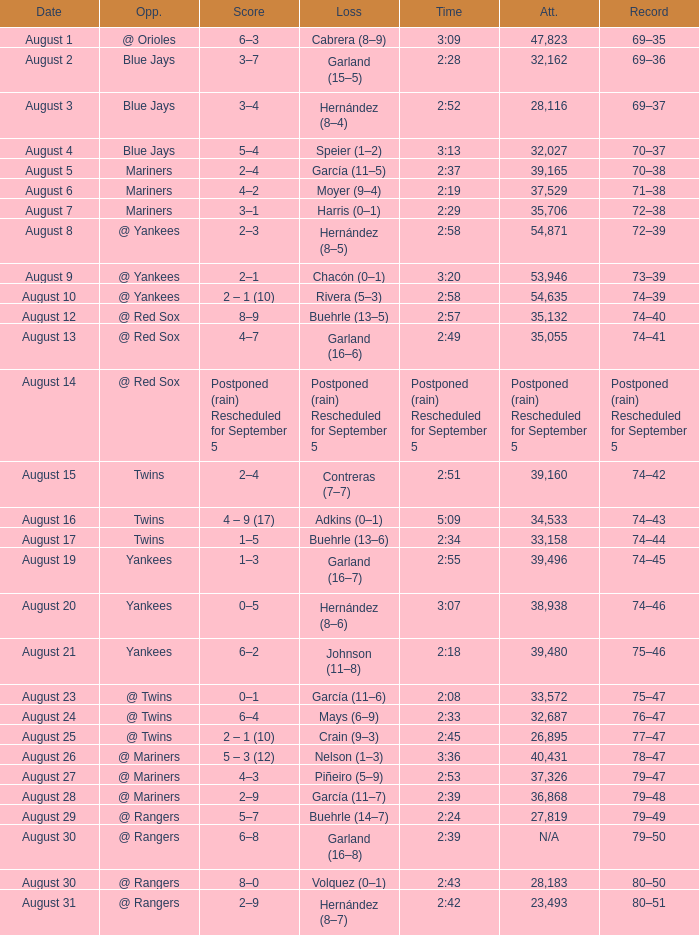Who lost with a time of 2:42? Hernández (8–7). 